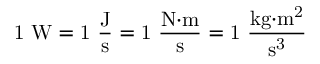Convert formula to latex. <formula><loc_0><loc_0><loc_500><loc_500>1 W = 1 { \frac { J } { s } } = 1 { \frac { N { \cdot } m } { s } } = 1 { \frac { k g { \cdot } m ^ { 2 } } { s ^ { 3 } } }</formula> 